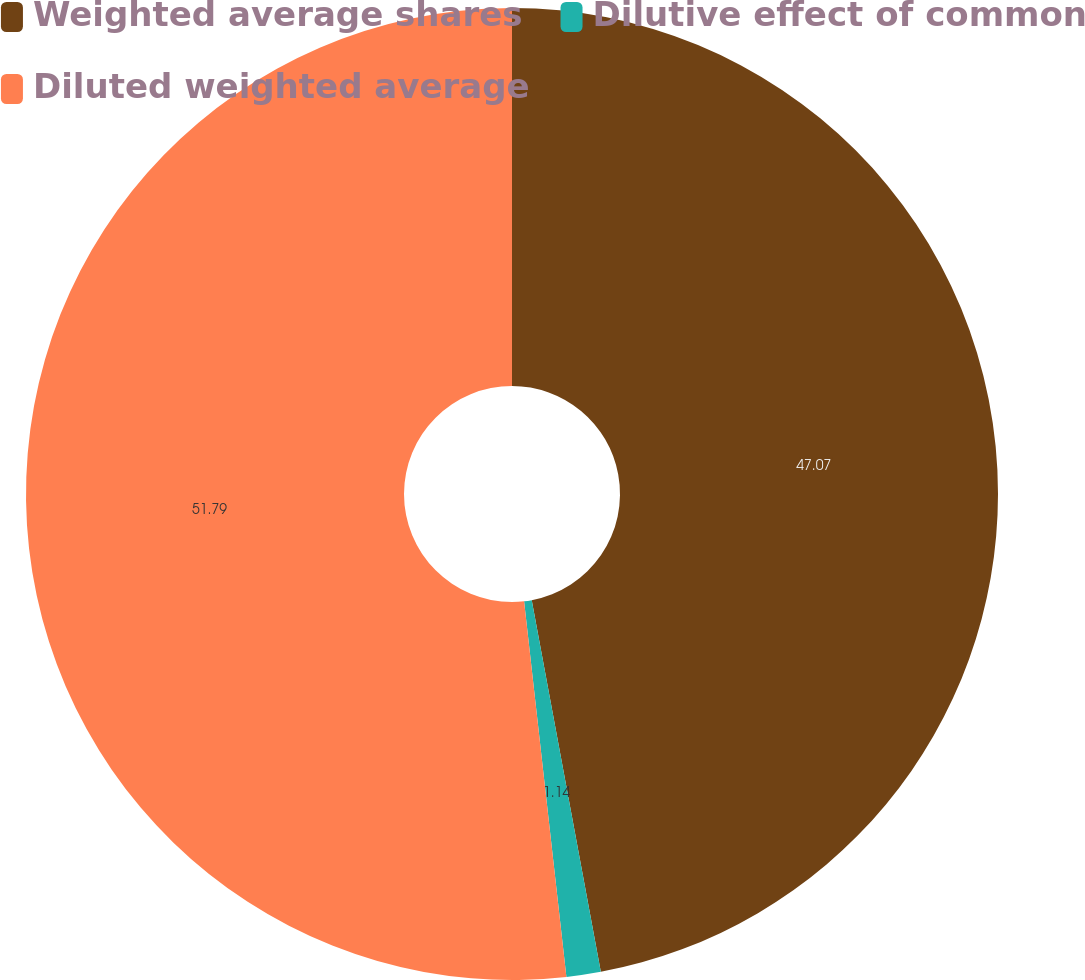<chart> <loc_0><loc_0><loc_500><loc_500><pie_chart><fcel>Weighted average shares<fcel>Dilutive effect of common<fcel>Diluted weighted average<nl><fcel>47.07%<fcel>1.14%<fcel>51.78%<nl></chart> 